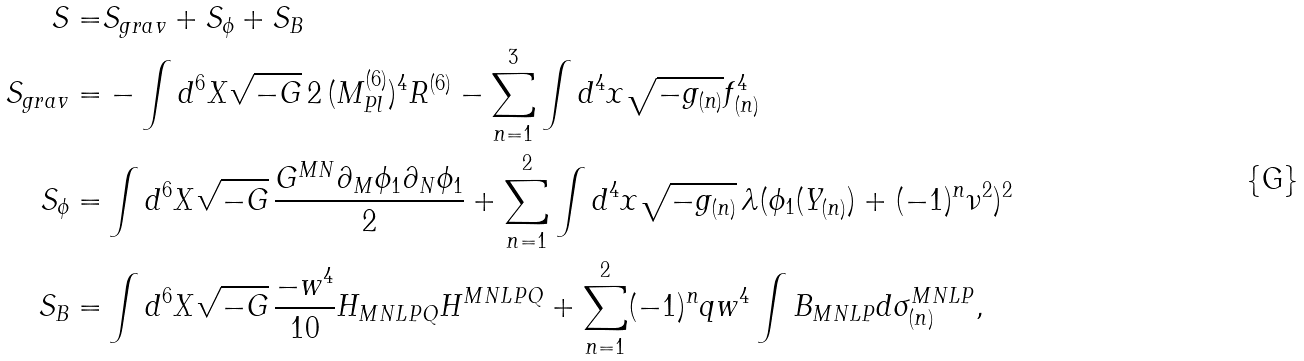Convert formula to latex. <formula><loc_0><loc_0><loc_500><loc_500>S = & S _ { g r a v } + S _ { \phi } + S _ { B } \\ S _ { g r a v } = & - \int d ^ { 6 } X \sqrt { - G } \, 2 \, ( M ^ { ( 6 ) } _ { P l } ) ^ { 4 } R ^ { ( 6 ) } - \sum _ { n = 1 } ^ { 3 } \int d ^ { 4 } x \sqrt { - g _ { ( n ) } } f ^ { 4 } _ { ( n ) } \\ S _ { \phi } = & \int d ^ { 6 } X \sqrt { - G } \, \frac { G ^ { M N } \partial _ { M } \phi _ { 1 } \partial _ { N } \phi _ { 1 } } { 2 } + \sum _ { n = 1 } ^ { 2 } \int d ^ { 4 } x \sqrt { - g _ { ( n ) } } \, \lambda ( \phi _ { 1 } ( Y _ { ( n ) } ) + ( - 1 ) ^ { n } \nu ^ { 2 } ) ^ { 2 } \\ S _ { B } = & \int d ^ { 6 } X \sqrt { - G } \, \frac { - w ^ { 4 } } { 1 0 } H _ { M N L P Q } H ^ { M N L P Q } + \sum _ { n = 1 } ^ { 2 } ( - 1 ) ^ { n } q w ^ { 4 } \int B _ { M N L P } d \sigma _ { ( n ) } ^ { M N L P } ,</formula> 